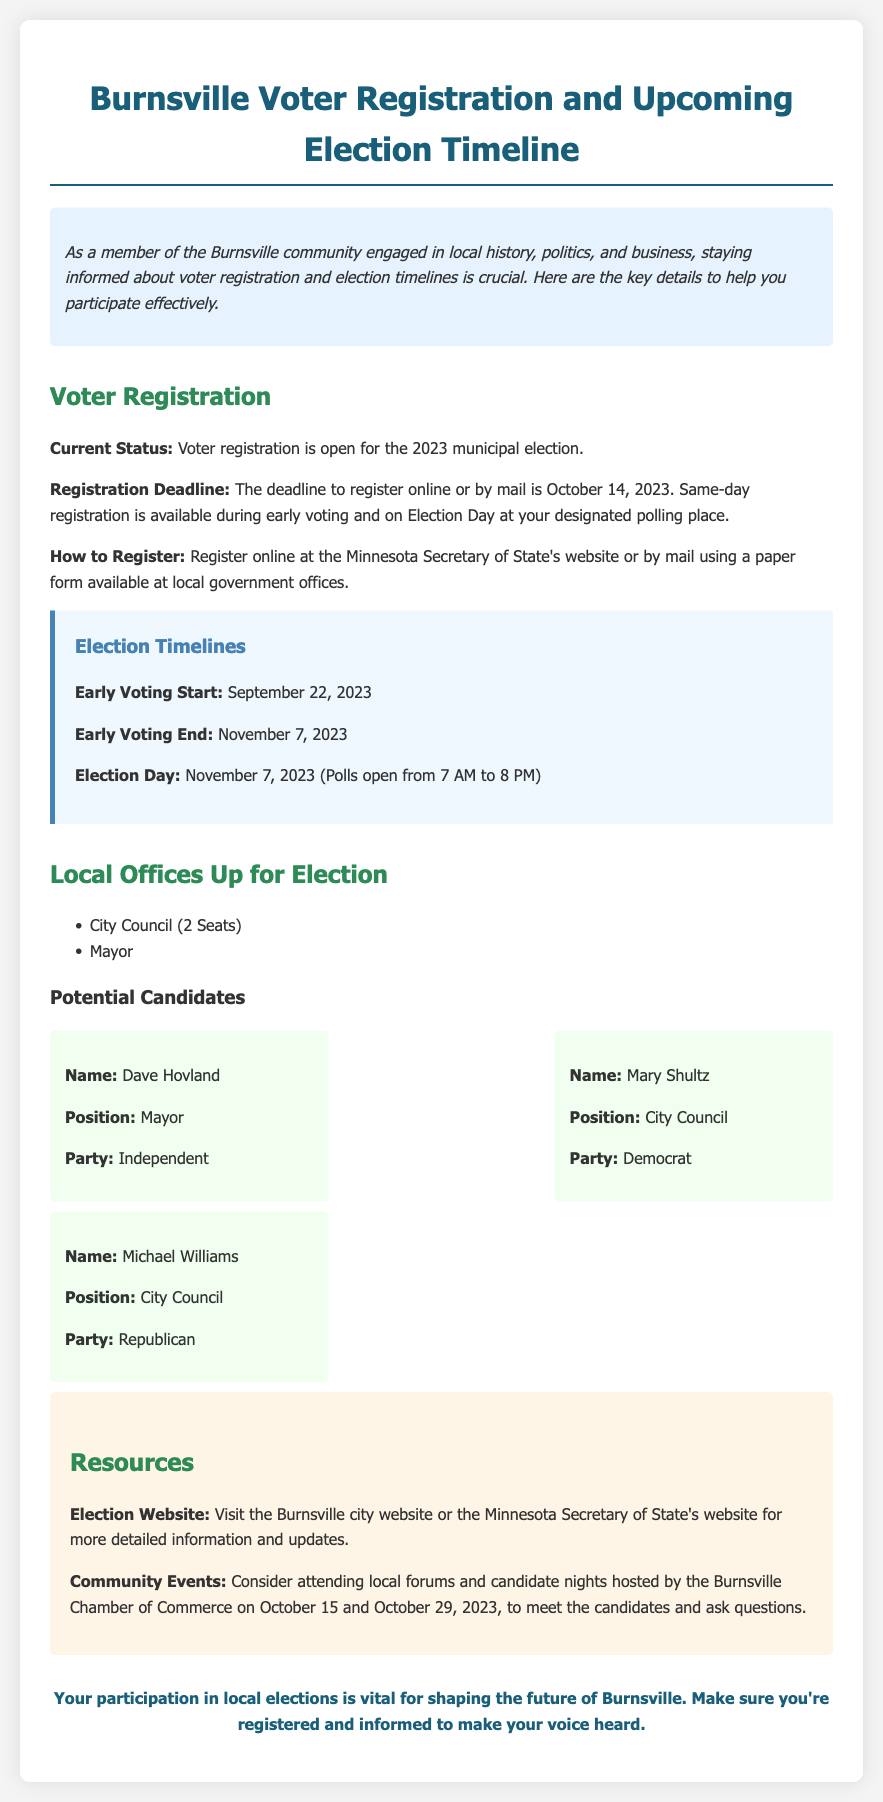What is the registration deadline for the municipal election? The registration deadline for the municipal election is specified in the document.
Answer: October 14, 2023 When does early voting begin? The document lists the early voting start date.
Answer: September 22, 2023 How many City Council seats are up for election? This number is provided in the section about local offices up for election.
Answer: 2 Seats Who is running for Mayor? The document includes potential candidates for the Mayor position.
Answer: Dave Hovland On what date is Election Day? The document explicitly states the date of the Election Day.
Answer: November 7, 2023 What party does Michael Williams represent? The candidate's party affiliation is mentioned in the document.
Answer: Republican What community events are scheduled before the election? The document details upcoming events related to the election.
Answer: Local forums and candidate nights Is same-day registration available? The document explains the voter registration options available.
Answer: Yes What color is used for the section titles in the document? The visual design of the document indicates the color for section titles.
Answer: Green 